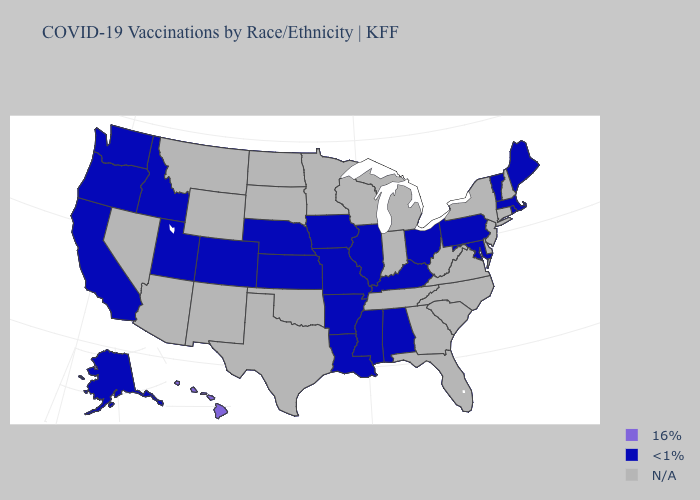Name the states that have a value in the range <1%?
Keep it brief. Alabama, Alaska, Arkansas, California, Colorado, Idaho, Illinois, Iowa, Kansas, Kentucky, Louisiana, Maine, Maryland, Massachusetts, Mississippi, Missouri, Nebraska, Ohio, Oregon, Pennsylvania, Rhode Island, Utah, Vermont, Washington. Does Missouri have the lowest value in the USA?
Quick response, please. Yes. Name the states that have a value in the range 16%?
Be succinct. Hawaii. Does Hawaii have the highest value in the USA?
Write a very short answer. Yes. Is the legend a continuous bar?
Answer briefly. No. What is the lowest value in states that border Ohio?
Quick response, please. <1%. Which states have the lowest value in the MidWest?
Keep it brief. Illinois, Iowa, Kansas, Missouri, Nebraska, Ohio. What is the highest value in the South ?
Quick response, please. <1%. What is the value of Virginia?
Short answer required. N/A. What is the highest value in states that border Nebraska?
Concise answer only. <1%. Name the states that have a value in the range <1%?
Short answer required. Alabama, Alaska, Arkansas, California, Colorado, Idaho, Illinois, Iowa, Kansas, Kentucky, Louisiana, Maine, Maryland, Massachusetts, Mississippi, Missouri, Nebraska, Ohio, Oregon, Pennsylvania, Rhode Island, Utah, Vermont, Washington. What is the value of Minnesota?
Quick response, please. N/A. Which states have the highest value in the USA?
Quick response, please. Hawaii. 